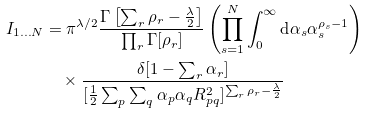Convert formula to latex. <formula><loc_0><loc_0><loc_500><loc_500>I _ { 1 \dots N } & = \pi ^ { \lambda / 2 } \frac { \Gamma \left [ \sum _ { r } \rho _ { r } - \frac { \lambda } { 2 } \right ] } { \prod _ { r } \Gamma [ \rho _ { r } ] } \left ( \prod _ { s = 1 } ^ { N } \int _ { 0 } ^ { \infty } \text {d} \alpha _ { s } \alpha _ { s } ^ { \rho _ { s } - 1 } \right ) \\ & \quad \times \frac { \delta [ 1 - \sum _ { r } \alpha _ { r } ] } { [ \frac { 1 } { 2 } \sum _ { p } \sum _ { q } \alpha _ { p } \alpha _ { q } R _ { p q } ^ { 2 } ] ^ { \sum _ { r } \rho _ { r } - \frac { \lambda } { 2 } } }</formula> 